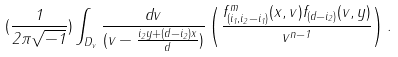Convert formula to latex. <formula><loc_0><loc_0><loc_500><loc_500>( \frac { 1 } { 2 \pi \sqrt { - 1 } } ) \int _ { D _ { v } } \frac { d v } { ( v - \frac { i _ { 2 } y + ( d - i _ { 2 } ) x } { d } ) } \left ( \frac { f ^ { m } _ { ( i _ { 1 } , i _ { 2 } - i _ { 1 } ) } ( x , v ) f _ { ( d - i _ { 2 } ) } ( v , y ) } { v ^ { n - 1 } } \right ) .</formula> 